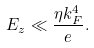Convert formula to latex. <formula><loc_0><loc_0><loc_500><loc_500>E _ { z } \ll \frac { \eta k _ { F } ^ { 4 } } { e } .</formula> 